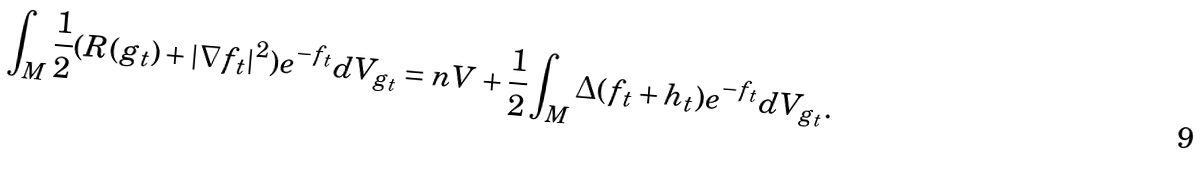<formula> <loc_0><loc_0><loc_500><loc_500>\int _ { M } \frac { 1 } { 2 } ( R ( g _ { t } ) + | \nabla f _ { t } | ^ { 2 } ) e ^ { - f _ { t } } d V _ { g _ { t } } = n V + \frac { 1 } { 2 } \int _ { M } \Delta ( f _ { t } + h _ { t } ) e ^ { - f _ { t } } d V _ { g _ { t } } .</formula> 